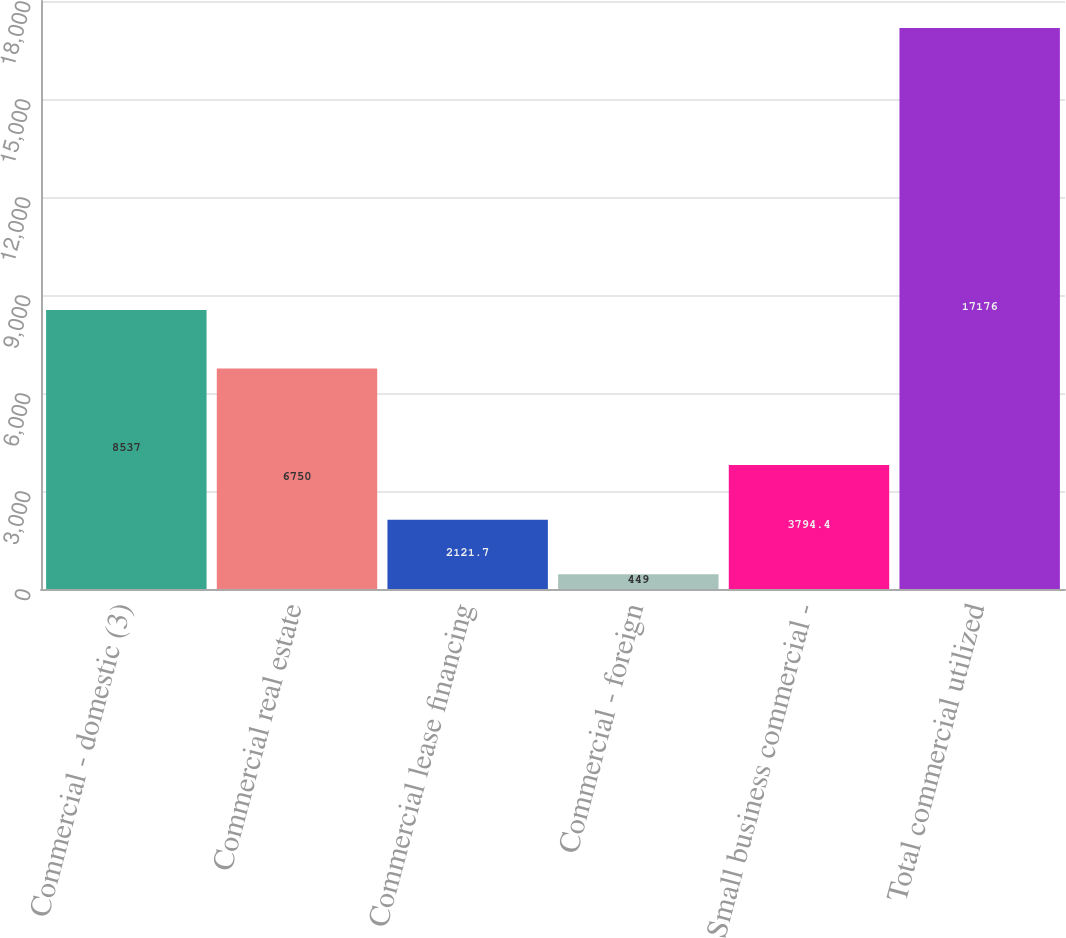<chart> <loc_0><loc_0><loc_500><loc_500><bar_chart><fcel>Commercial - domestic (3)<fcel>Commercial real estate<fcel>Commercial lease financing<fcel>Commercial - foreign<fcel>Small business commercial -<fcel>Total commercial utilized<nl><fcel>8537<fcel>6750<fcel>2121.7<fcel>449<fcel>3794.4<fcel>17176<nl></chart> 